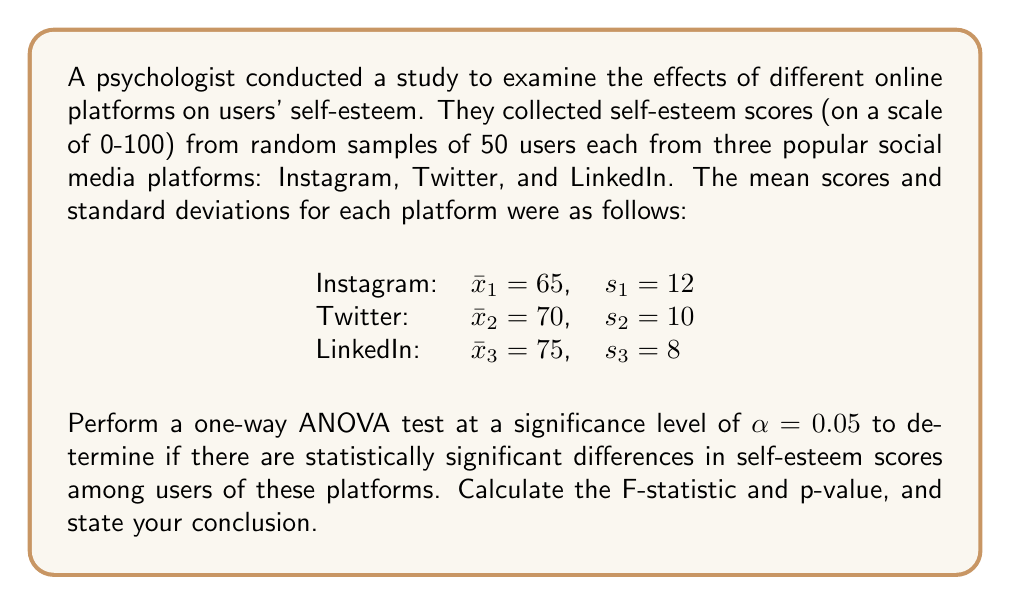Provide a solution to this math problem. To perform a one-way ANOVA test, we need to follow these steps:

1. Calculate the sum of squares between groups (SSB)
2. Calculate the sum of squares within groups (SSW)
3. Calculate the degrees of freedom (df)
4. Calculate the mean square between groups (MSB) and mean square within groups (MSW)
5. Calculate the F-statistic
6. Determine the critical F-value and p-value
7. Make a conclusion

Step 1: Calculate SSB
$$SSB = \sum_{i=1}^k n_i(\bar{x}_i - \bar{x})^2$$
Where $k$ is the number of groups, $n_i$ is the sample size of each group, $\bar{x}_i$ is the mean of each group, and $\bar{x}$ is the grand mean.

First, calculate the grand mean:
$$\bar{x} = \frac{65 + 70 + 75}{3} = 70$$

Now, calculate SSB:
$$SSB = 50(65 - 70)^2 + 50(70 - 70)^2 + 50(75 - 70)^2 = 2500$$

Step 2: Calculate SSW
$$SSW = \sum_{i=1}^k (n_i - 1)s_i^2$$

$$SSW = 49(12^2) + 49(10^2) + 49(8^2) = 13720$$

Step 3: Calculate degrees of freedom
$$df_{between} = k - 1 = 3 - 1 = 2$$
$$df_{within} = N - k = 150 - 3 = 147$$
Where $N$ is the total sample size.

Step 4: Calculate MSB and MSW
$$MSB = \frac{SSB}{df_{between}} = \frac{2500}{2} = 1250$$
$$MSW = \frac{SSW}{df_{within}} = \frac{13720}{147} \approx 93.33$$

Step 5: Calculate F-statistic
$$F = \frac{MSB}{MSW} = \frac{1250}{93.33} \approx 13.39$$

Step 6: Determine critical F-value and p-value
Using an F-distribution table or calculator with $df_{between} = 2$ and $df_{within} = 147$, we find:
Critical F-value (at $\alpha = 0.05$): $F_{crit} \approx 3.06$
p-value: $p < 0.001$

Step 7: Make a conclusion
Since $F = 13.39 > F_{crit} = 3.06$ and $p < 0.001 < \alpha = 0.05$, we reject the null hypothesis.
Answer: F-statistic: 13.39
p-value: < 0.001

Conclusion: There is strong evidence to suggest that there are statistically significant differences in self-esteem scores among users of Instagram, Twitter, and LinkedIn (F(2, 147) = 13.39, p < 0.001). 